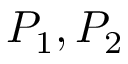Convert formula to latex. <formula><loc_0><loc_0><loc_500><loc_500>P _ { 1 } , P _ { 2 }</formula> 